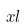Convert formula to latex. <formula><loc_0><loc_0><loc_500><loc_500>x l</formula> 